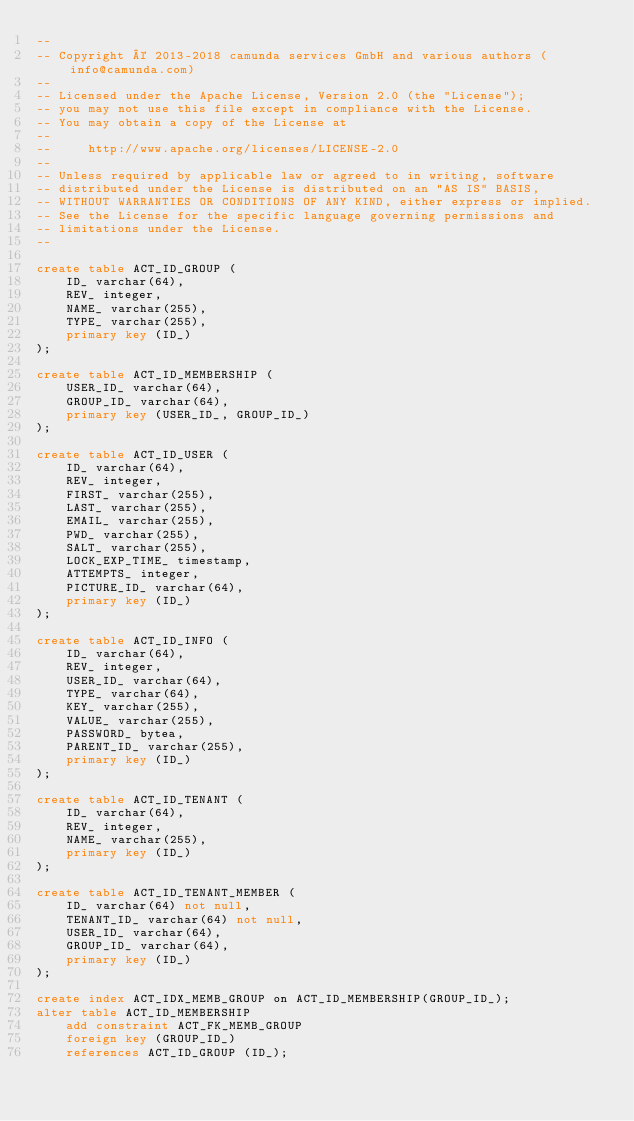<code> <loc_0><loc_0><loc_500><loc_500><_SQL_>--
-- Copyright © 2013-2018 camunda services GmbH and various authors (info@camunda.com)
--
-- Licensed under the Apache License, Version 2.0 (the "License");
-- you may not use this file except in compliance with the License.
-- You may obtain a copy of the License at
--
--     http://www.apache.org/licenses/LICENSE-2.0
--
-- Unless required by applicable law or agreed to in writing, software
-- distributed under the License is distributed on an "AS IS" BASIS,
-- WITHOUT WARRANTIES OR CONDITIONS OF ANY KIND, either express or implied.
-- See the License for the specific language governing permissions and
-- limitations under the License.
--

create table ACT_ID_GROUP (
    ID_ varchar(64),
    REV_ integer,
    NAME_ varchar(255),
    TYPE_ varchar(255),
    primary key (ID_)
);

create table ACT_ID_MEMBERSHIP (
    USER_ID_ varchar(64),
    GROUP_ID_ varchar(64),
    primary key (USER_ID_, GROUP_ID_)
);

create table ACT_ID_USER (
    ID_ varchar(64),
    REV_ integer,
    FIRST_ varchar(255),
    LAST_ varchar(255),
    EMAIL_ varchar(255),
    PWD_ varchar(255),
    SALT_ varchar(255),
    LOCK_EXP_TIME_ timestamp,
    ATTEMPTS_ integer,
    PICTURE_ID_ varchar(64),
    primary key (ID_)
);

create table ACT_ID_INFO (
    ID_ varchar(64),
    REV_ integer,
    USER_ID_ varchar(64),
    TYPE_ varchar(64),
    KEY_ varchar(255),
    VALUE_ varchar(255),
    PASSWORD_ bytea,
    PARENT_ID_ varchar(255),
    primary key (ID_)
);

create table ACT_ID_TENANT (
    ID_ varchar(64),
    REV_ integer,
    NAME_ varchar(255),
    primary key (ID_)
);

create table ACT_ID_TENANT_MEMBER (
    ID_ varchar(64) not null,
    TENANT_ID_ varchar(64) not null,
    USER_ID_ varchar(64),
    GROUP_ID_ varchar(64),
    primary key (ID_)
);

create index ACT_IDX_MEMB_GROUP on ACT_ID_MEMBERSHIP(GROUP_ID_);
alter table ACT_ID_MEMBERSHIP
    add constraint ACT_FK_MEMB_GROUP
    foreign key (GROUP_ID_)
    references ACT_ID_GROUP (ID_);
</code> 